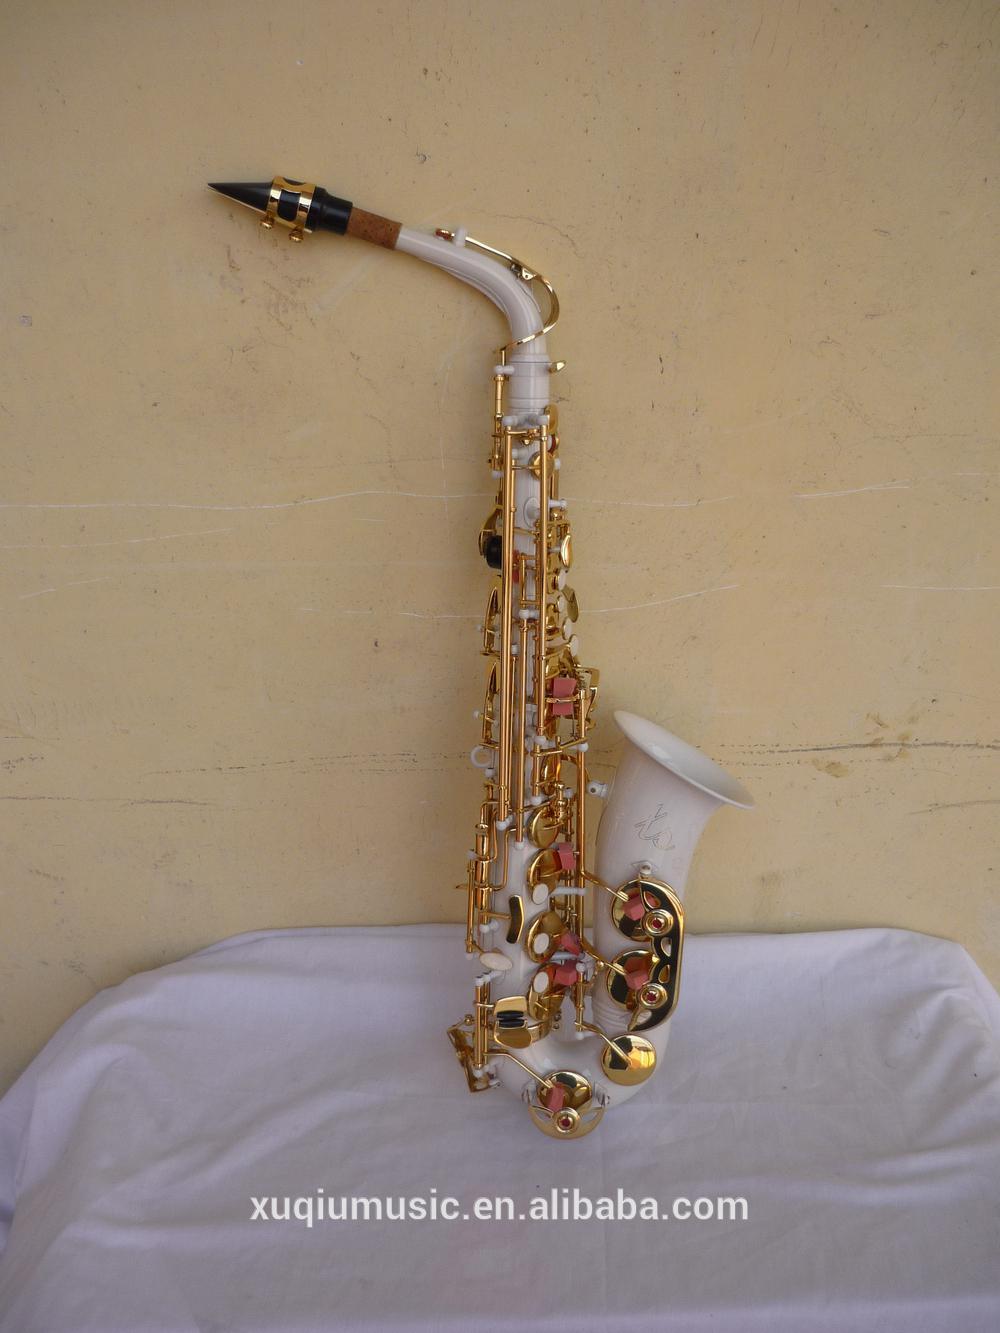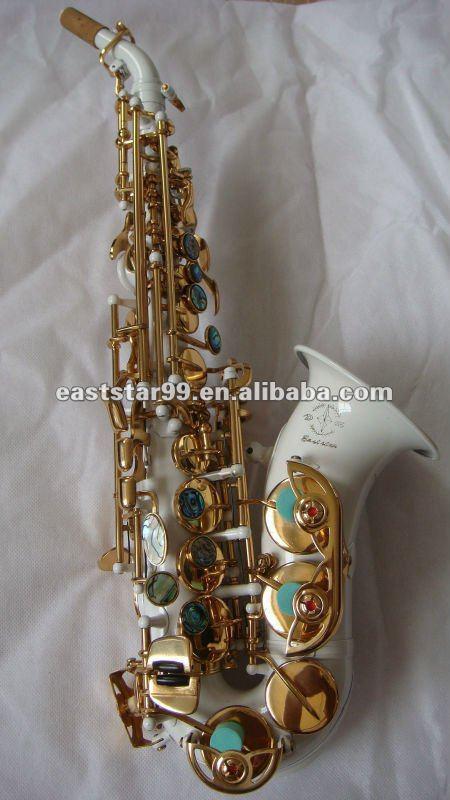The first image is the image on the left, the second image is the image on the right. Given the left and right images, does the statement "The left image shows a white saxophone witht turquoise on its gold buttons and its upturned bell facing right, and the right image shows a straight white instrument with its bell at the bottom." hold true? Answer yes or no. No. 